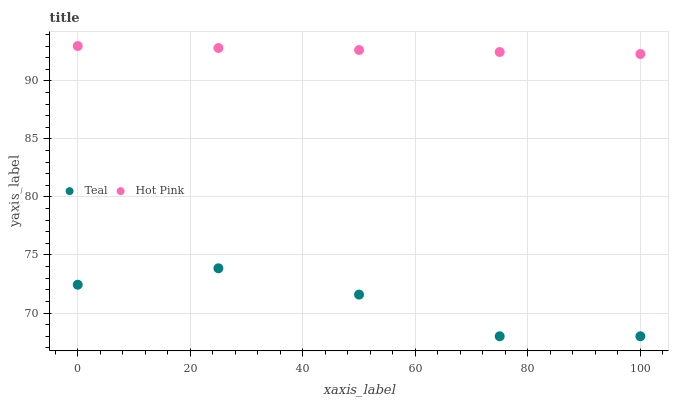Does Teal have the minimum area under the curve?
Answer yes or no. Yes. Does Hot Pink have the maximum area under the curve?
Answer yes or no. Yes. Does Teal have the maximum area under the curve?
Answer yes or no. No. Is Hot Pink the smoothest?
Answer yes or no. Yes. Is Teal the roughest?
Answer yes or no. Yes. Is Teal the smoothest?
Answer yes or no. No. Does Teal have the lowest value?
Answer yes or no. Yes. Does Hot Pink have the highest value?
Answer yes or no. Yes. Does Teal have the highest value?
Answer yes or no. No. Is Teal less than Hot Pink?
Answer yes or no. Yes. Is Hot Pink greater than Teal?
Answer yes or no. Yes. Does Teal intersect Hot Pink?
Answer yes or no. No. 